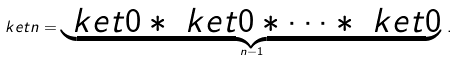<formula> <loc_0><loc_0><loc_500><loc_500>\ k e t { n } = \underbrace { \ k e t { 0 } \ast \ k e t { 0 } \ast \dots \ast \ k e t { 0 } } _ { n - 1 } \, .</formula> 